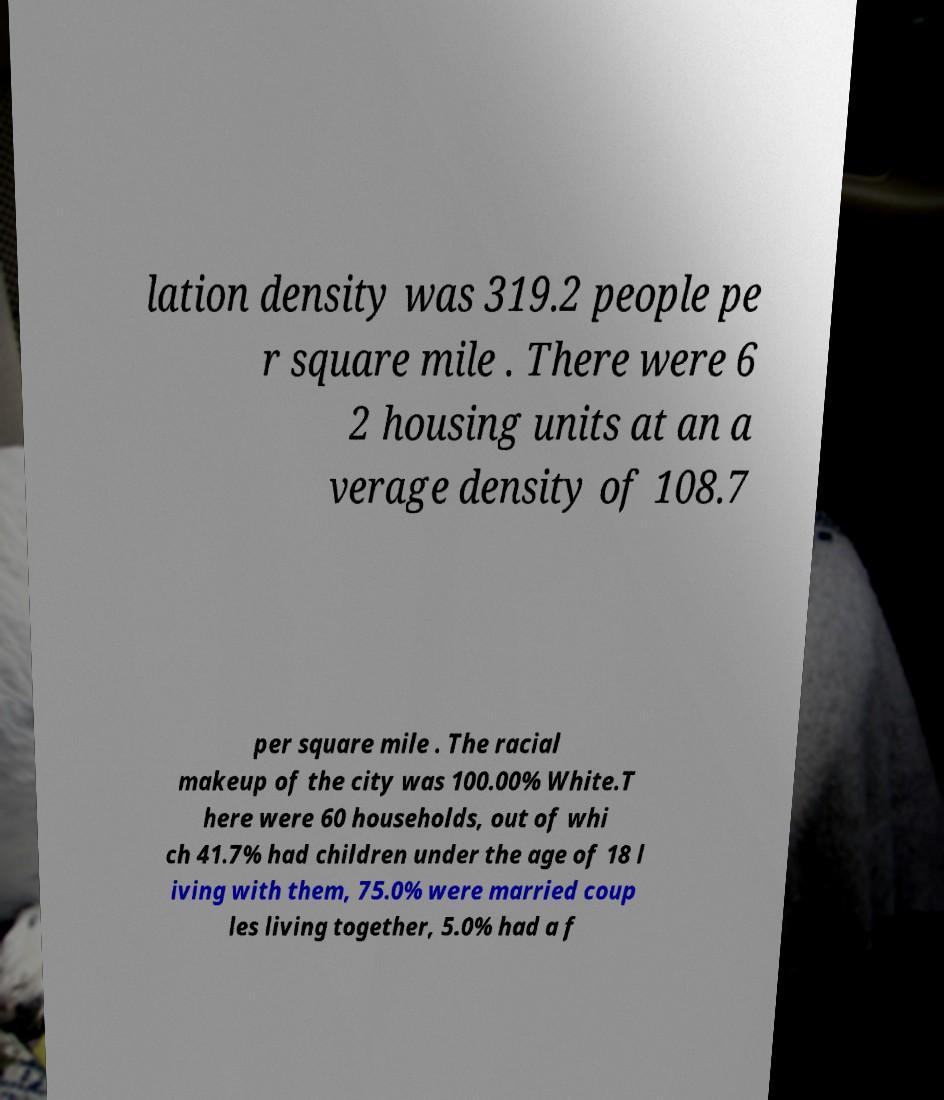I need the written content from this picture converted into text. Can you do that? lation density was 319.2 people pe r square mile . There were 6 2 housing units at an a verage density of 108.7 per square mile . The racial makeup of the city was 100.00% White.T here were 60 households, out of whi ch 41.7% had children under the age of 18 l iving with them, 75.0% were married coup les living together, 5.0% had a f 